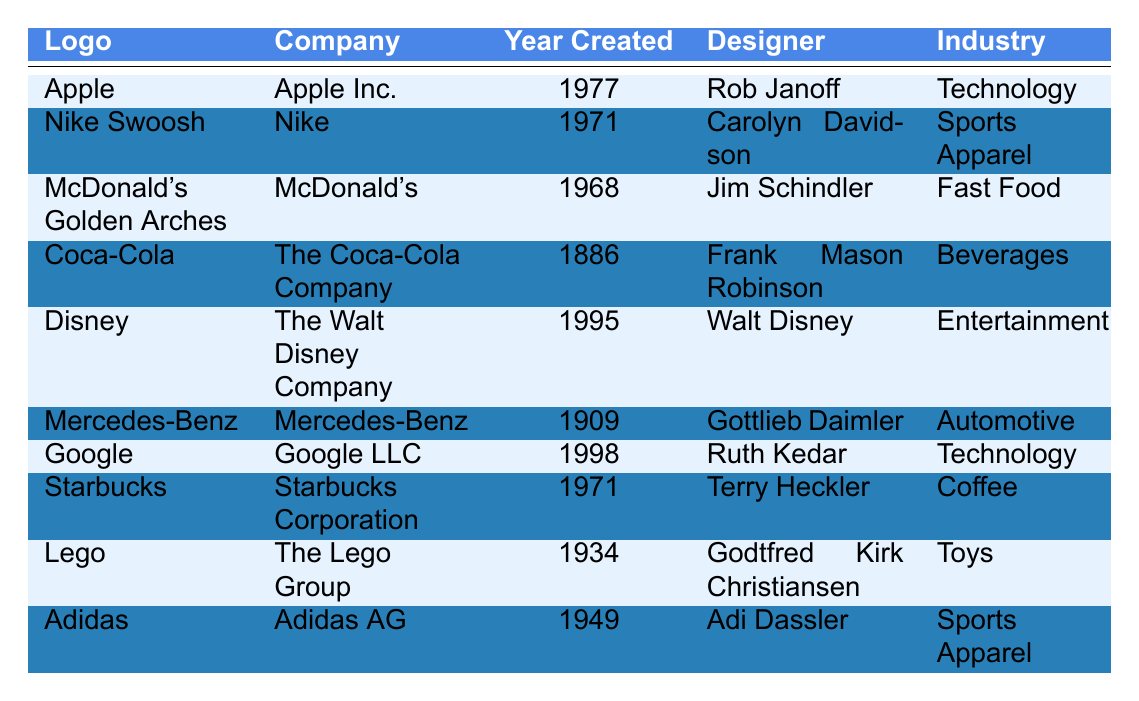What year was the logo for Nike created? By checking the "Year Created" column for the row containing "Nike Swoosh," we see it was created in 1971.
Answer: 1971 Who designed the Coca-Cola logo? The table indicates that the designer listed for the Coca-Cola logo is Frank Mason Robinson.
Answer: Frank Mason Robinson Which company has a logo that was created in 1995? Looking through the "Year Created" column, we find that the logo created in 1995 belongs to The Walt Disney Company.
Answer: The Walt Disney Company Is the Adidas logo from the 20th century? The "Year Created" for the Adidas logo is 1949, which falls within the 20th century.
Answer: Yes How many years apart were the creations of the Mercedes-Benz and the Apple logos? The Mercedes-Benz logo was created in 1909 and the Apple logo in 1977. We subtract 1909 from 1977, which gives us 68 years.
Answer: 68 years Which industry does the Starbuck's logo belong to? Referring to the "Industry" column for Starbucks, it is listed as Coffee.
Answer: Coffee Identify the most recent logo created from the table. The table shows that the most recent logo is Google's, created in 1998.
Answer: Google How many logos listed are for companies in the technology industry? By checking the "Industry" column, both Apple and Google are listed in Technology, leading to a total of 2 logos.
Answer: 2 Does the logo for Lego belong to the Food & Beverage industry? Checking the "Industry" column, Lego is listed under Toys, not Food & Beverage. Therefore, the answer is no.
Answer: No Which logo was designed by Ruth Kedar? The table shows Ruth Kedar designed the Google logo.
Answer: Google What was the creation year of the oldest logo in the table? The Coca-Cola logo, created in 1886, is the oldest according to the "Year Created" column.
Answer: 1886 How many logos were created in the 1970s? The logos for Nike (1971) and Apple (1977) were created in the 1970s, giving a total of 2 logos.
Answer: 2 Which logo is associated with the Fast Food industry? According to the "Industry" column, McDonald's Golden Arches is listed under Fast Food.
Answer: McDonald's Golden Arches 